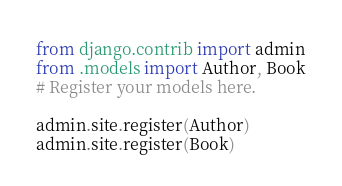Convert code to text. <code><loc_0><loc_0><loc_500><loc_500><_Python_>from django.contrib import admin
from .models import Author, Book
# Register your models here.

admin.site.register(Author)
admin.site.register(Book)</code> 